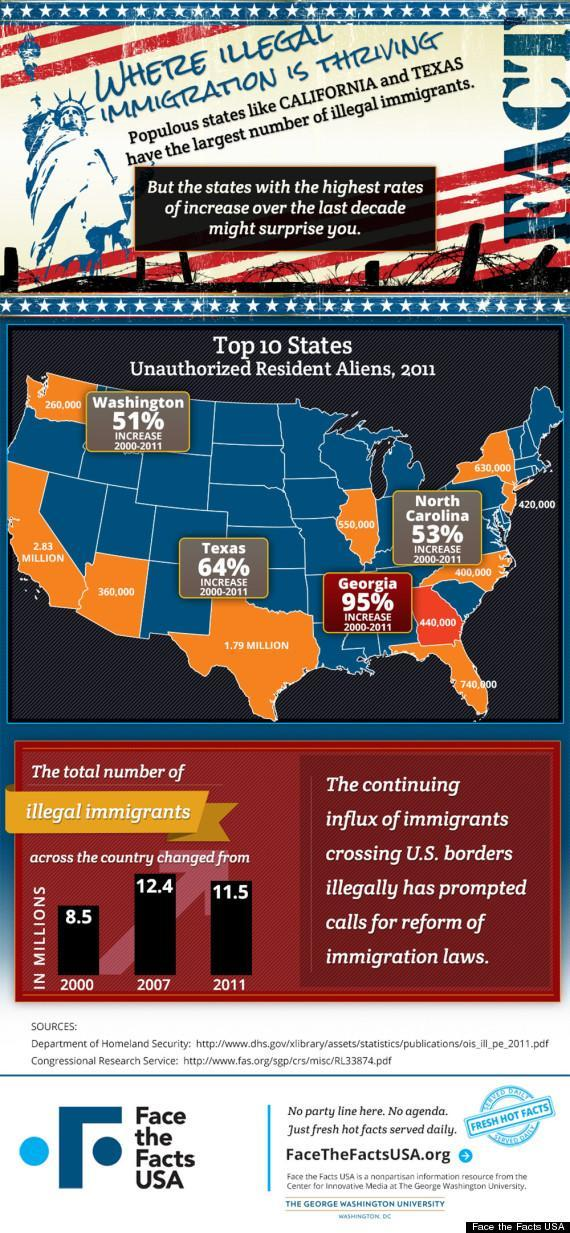what is the percentage increase in unauthorized resident aliens in 2000-2011 in Texas?
Answer the question with a short phrase. 64 